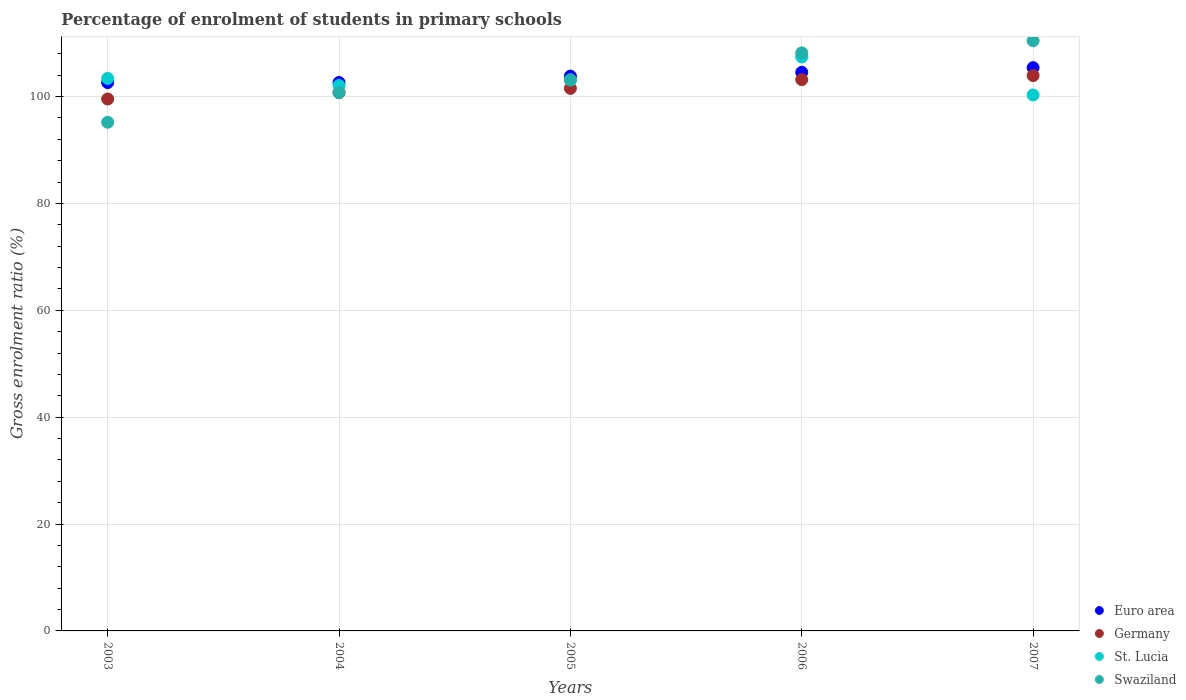How many different coloured dotlines are there?
Offer a very short reply. 4. What is the percentage of students enrolled in primary schools in St. Lucia in 2007?
Your answer should be compact. 100.3. Across all years, what is the maximum percentage of students enrolled in primary schools in Swaziland?
Keep it short and to the point. 110.46. Across all years, what is the minimum percentage of students enrolled in primary schools in Euro area?
Offer a very short reply. 102.61. In which year was the percentage of students enrolled in primary schools in Swaziland minimum?
Offer a terse response. 2003. What is the total percentage of students enrolled in primary schools in Germany in the graph?
Provide a short and direct response. 508.88. What is the difference between the percentage of students enrolled in primary schools in Euro area in 2003 and that in 2005?
Give a very brief answer. -1.21. What is the difference between the percentage of students enrolled in primary schools in Germany in 2006 and the percentage of students enrolled in primary schools in St. Lucia in 2007?
Offer a very short reply. 2.87. What is the average percentage of students enrolled in primary schools in Swaziland per year?
Offer a terse response. 103.54. In the year 2005, what is the difference between the percentage of students enrolled in primary schools in Euro area and percentage of students enrolled in primary schools in Swaziland?
Offer a very short reply. 0.67. In how many years, is the percentage of students enrolled in primary schools in Swaziland greater than 100 %?
Your answer should be very brief. 4. What is the ratio of the percentage of students enrolled in primary schools in Euro area in 2003 to that in 2005?
Offer a terse response. 0.99. What is the difference between the highest and the second highest percentage of students enrolled in primary schools in Euro area?
Provide a short and direct response. 0.86. What is the difference between the highest and the lowest percentage of students enrolled in primary schools in Euro area?
Keep it short and to the point. 2.79. Does the percentage of students enrolled in primary schools in St. Lucia monotonically increase over the years?
Offer a terse response. No. Is the percentage of students enrolled in primary schools in St. Lucia strictly greater than the percentage of students enrolled in primary schools in Swaziland over the years?
Give a very brief answer. No. How many years are there in the graph?
Keep it short and to the point. 5. What is the difference between two consecutive major ticks on the Y-axis?
Your response must be concise. 20. Are the values on the major ticks of Y-axis written in scientific E-notation?
Offer a terse response. No. Does the graph contain any zero values?
Provide a succinct answer. No. Where does the legend appear in the graph?
Make the answer very short. Bottom right. What is the title of the graph?
Provide a short and direct response. Percentage of enrolment of students in primary schools. What is the Gross enrolment ratio (%) in Euro area in 2003?
Your response must be concise. 102.61. What is the Gross enrolment ratio (%) of Germany in 2003?
Give a very brief answer. 99.54. What is the Gross enrolment ratio (%) of St. Lucia in 2003?
Make the answer very short. 103.39. What is the Gross enrolment ratio (%) of Swaziland in 2003?
Your answer should be compact. 95.19. What is the Gross enrolment ratio (%) in Euro area in 2004?
Offer a very short reply. 102.63. What is the Gross enrolment ratio (%) of Germany in 2004?
Provide a short and direct response. 100.72. What is the Gross enrolment ratio (%) in St. Lucia in 2004?
Your response must be concise. 102.07. What is the Gross enrolment ratio (%) of Swaziland in 2004?
Offer a very short reply. 100.73. What is the Gross enrolment ratio (%) of Euro area in 2005?
Give a very brief answer. 103.82. What is the Gross enrolment ratio (%) in Germany in 2005?
Ensure brevity in your answer.  101.53. What is the Gross enrolment ratio (%) of St. Lucia in 2005?
Provide a short and direct response. 103.08. What is the Gross enrolment ratio (%) in Swaziland in 2005?
Provide a short and direct response. 103.14. What is the Gross enrolment ratio (%) in Euro area in 2006?
Give a very brief answer. 104.54. What is the Gross enrolment ratio (%) of Germany in 2006?
Your answer should be compact. 103.17. What is the Gross enrolment ratio (%) of St. Lucia in 2006?
Give a very brief answer. 107.41. What is the Gross enrolment ratio (%) of Swaziland in 2006?
Ensure brevity in your answer.  108.17. What is the Gross enrolment ratio (%) in Euro area in 2007?
Ensure brevity in your answer.  105.4. What is the Gross enrolment ratio (%) in Germany in 2007?
Ensure brevity in your answer.  103.93. What is the Gross enrolment ratio (%) in St. Lucia in 2007?
Give a very brief answer. 100.3. What is the Gross enrolment ratio (%) of Swaziland in 2007?
Make the answer very short. 110.46. Across all years, what is the maximum Gross enrolment ratio (%) of Euro area?
Give a very brief answer. 105.4. Across all years, what is the maximum Gross enrolment ratio (%) of Germany?
Offer a very short reply. 103.93. Across all years, what is the maximum Gross enrolment ratio (%) in St. Lucia?
Offer a very short reply. 107.41. Across all years, what is the maximum Gross enrolment ratio (%) in Swaziland?
Offer a terse response. 110.46. Across all years, what is the minimum Gross enrolment ratio (%) in Euro area?
Your response must be concise. 102.61. Across all years, what is the minimum Gross enrolment ratio (%) of Germany?
Provide a short and direct response. 99.54. Across all years, what is the minimum Gross enrolment ratio (%) of St. Lucia?
Provide a succinct answer. 100.3. Across all years, what is the minimum Gross enrolment ratio (%) in Swaziland?
Make the answer very short. 95.19. What is the total Gross enrolment ratio (%) in Euro area in the graph?
Make the answer very short. 519. What is the total Gross enrolment ratio (%) in Germany in the graph?
Your answer should be very brief. 508.88. What is the total Gross enrolment ratio (%) of St. Lucia in the graph?
Your answer should be compact. 516.24. What is the total Gross enrolment ratio (%) of Swaziland in the graph?
Offer a very short reply. 517.69. What is the difference between the Gross enrolment ratio (%) in Euro area in 2003 and that in 2004?
Ensure brevity in your answer.  -0.02. What is the difference between the Gross enrolment ratio (%) of Germany in 2003 and that in 2004?
Provide a succinct answer. -1.18. What is the difference between the Gross enrolment ratio (%) in St. Lucia in 2003 and that in 2004?
Offer a very short reply. 1.33. What is the difference between the Gross enrolment ratio (%) of Swaziland in 2003 and that in 2004?
Make the answer very short. -5.55. What is the difference between the Gross enrolment ratio (%) in Euro area in 2003 and that in 2005?
Keep it short and to the point. -1.21. What is the difference between the Gross enrolment ratio (%) of Germany in 2003 and that in 2005?
Your response must be concise. -1.99. What is the difference between the Gross enrolment ratio (%) of St. Lucia in 2003 and that in 2005?
Your answer should be compact. 0.31. What is the difference between the Gross enrolment ratio (%) of Swaziland in 2003 and that in 2005?
Provide a succinct answer. -7.96. What is the difference between the Gross enrolment ratio (%) of Euro area in 2003 and that in 2006?
Your answer should be compact. -1.93. What is the difference between the Gross enrolment ratio (%) of Germany in 2003 and that in 2006?
Give a very brief answer. -3.63. What is the difference between the Gross enrolment ratio (%) in St. Lucia in 2003 and that in 2006?
Offer a terse response. -4.01. What is the difference between the Gross enrolment ratio (%) in Swaziland in 2003 and that in 2006?
Offer a terse response. -12.98. What is the difference between the Gross enrolment ratio (%) in Euro area in 2003 and that in 2007?
Give a very brief answer. -2.79. What is the difference between the Gross enrolment ratio (%) in Germany in 2003 and that in 2007?
Give a very brief answer. -4.39. What is the difference between the Gross enrolment ratio (%) of St. Lucia in 2003 and that in 2007?
Offer a very short reply. 3.1. What is the difference between the Gross enrolment ratio (%) in Swaziland in 2003 and that in 2007?
Your response must be concise. -15.27. What is the difference between the Gross enrolment ratio (%) of Euro area in 2004 and that in 2005?
Keep it short and to the point. -1.19. What is the difference between the Gross enrolment ratio (%) in Germany in 2004 and that in 2005?
Offer a very short reply. -0.81. What is the difference between the Gross enrolment ratio (%) in St. Lucia in 2004 and that in 2005?
Give a very brief answer. -1.02. What is the difference between the Gross enrolment ratio (%) in Swaziland in 2004 and that in 2005?
Provide a succinct answer. -2.41. What is the difference between the Gross enrolment ratio (%) of Euro area in 2004 and that in 2006?
Ensure brevity in your answer.  -1.91. What is the difference between the Gross enrolment ratio (%) in Germany in 2004 and that in 2006?
Your answer should be compact. -2.45. What is the difference between the Gross enrolment ratio (%) in St. Lucia in 2004 and that in 2006?
Keep it short and to the point. -5.34. What is the difference between the Gross enrolment ratio (%) of Swaziland in 2004 and that in 2006?
Make the answer very short. -7.43. What is the difference between the Gross enrolment ratio (%) of Euro area in 2004 and that in 2007?
Offer a terse response. -2.77. What is the difference between the Gross enrolment ratio (%) in Germany in 2004 and that in 2007?
Keep it short and to the point. -3.21. What is the difference between the Gross enrolment ratio (%) of St. Lucia in 2004 and that in 2007?
Ensure brevity in your answer.  1.77. What is the difference between the Gross enrolment ratio (%) of Swaziland in 2004 and that in 2007?
Provide a succinct answer. -9.72. What is the difference between the Gross enrolment ratio (%) in Euro area in 2005 and that in 2006?
Keep it short and to the point. -0.72. What is the difference between the Gross enrolment ratio (%) in Germany in 2005 and that in 2006?
Keep it short and to the point. -1.64. What is the difference between the Gross enrolment ratio (%) of St. Lucia in 2005 and that in 2006?
Provide a short and direct response. -4.32. What is the difference between the Gross enrolment ratio (%) in Swaziland in 2005 and that in 2006?
Your answer should be very brief. -5.02. What is the difference between the Gross enrolment ratio (%) of Euro area in 2005 and that in 2007?
Give a very brief answer. -1.58. What is the difference between the Gross enrolment ratio (%) in Germany in 2005 and that in 2007?
Your answer should be compact. -2.4. What is the difference between the Gross enrolment ratio (%) of St. Lucia in 2005 and that in 2007?
Offer a terse response. 2.79. What is the difference between the Gross enrolment ratio (%) in Swaziland in 2005 and that in 2007?
Provide a succinct answer. -7.31. What is the difference between the Gross enrolment ratio (%) in Euro area in 2006 and that in 2007?
Your answer should be very brief. -0.86. What is the difference between the Gross enrolment ratio (%) in Germany in 2006 and that in 2007?
Keep it short and to the point. -0.76. What is the difference between the Gross enrolment ratio (%) of St. Lucia in 2006 and that in 2007?
Provide a short and direct response. 7.11. What is the difference between the Gross enrolment ratio (%) in Swaziland in 2006 and that in 2007?
Your response must be concise. -2.29. What is the difference between the Gross enrolment ratio (%) in Euro area in 2003 and the Gross enrolment ratio (%) in Germany in 2004?
Your response must be concise. 1.89. What is the difference between the Gross enrolment ratio (%) in Euro area in 2003 and the Gross enrolment ratio (%) in St. Lucia in 2004?
Provide a succinct answer. 0.55. What is the difference between the Gross enrolment ratio (%) in Euro area in 2003 and the Gross enrolment ratio (%) in Swaziland in 2004?
Ensure brevity in your answer.  1.88. What is the difference between the Gross enrolment ratio (%) of Germany in 2003 and the Gross enrolment ratio (%) of St. Lucia in 2004?
Offer a very short reply. -2.53. What is the difference between the Gross enrolment ratio (%) in Germany in 2003 and the Gross enrolment ratio (%) in Swaziland in 2004?
Make the answer very short. -1.19. What is the difference between the Gross enrolment ratio (%) of St. Lucia in 2003 and the Gross enrolment ratio (%) of Swaziland in 2004?
Your answer should be very brief. 2.66. What is the difference between the Gross enrolment ratio (%) in Euro area in 2003 and the Gross enrolment ratio (%) in St. Lucia in 2005?
Offer a very short reply. -0.47. What is the difference between the Gross enrolment ratio (%) of Euro area in 2003 and the Gross enrolment ratio (%) of Swaziland in 2005?
Your response must be concise. -0.53. What is the difference between the Gross enrolment ratio (%) in Germany in 2003 and the Gross enrolment ratio (%) in St. Lucia in 2005?
Your answer should be compact. -3.54. What is the difference between the Gross enrolment ratio (%) in Germany in 2003 and the Gross enrolment ratio (%) in Swaziland in 2005?
Make the answer very short. -3.61. What is the difference between the Gross enrolment ratio (%) of St. Lucia in 2003 and the Gross enrolment ratio (%) of Swaziland in 2005?
Give a very brief answer. 0.25. What is the difference between the Gross enrolment ratio (%) of Euro area in 2003 and the Gross enrolment ratio (%) of Germany in 2006?
Provide a succinct answer. -0.56. What is the difference between the Gross enrolment ratio (%) of Euro area in 2003 and the Gross enrolment ratio (%) of St. Lucia in 2006?
Your answer should be very brief. -4.8. What is the difference between the Gross enrolment ratio (%) of Euro area in 2003 and the Gross enrolment ratio (%) of Swaziland in 2006?
Give a very brief answer. -5.56. What is the difference between the Gross enrolment ratio (%) of Germany in 2003 and the Gross enrolment ratio (%) of St. Lucia in 2006?
Provide a succinct answer. -7.87. What is the difference between the Gross enrolment ratio (%) of Germany in 2003 and the Gross enrolment ratio (%) of Swaziland in 2006?
Provide a succinct answer. -8.63. What is the difference between the Gross enrolment ratio (%) in St. Lucia in 2003 and the Gross enrolment ratio (%) in Swaziland in 2006?
Your answer should be compact. -4.78. What is the difference between the Gross enrolment ratio (%) in Euro area in 2003 and the Gross enrolment ratio (%) in Germany in 2007?
Your answer should be compact. -1.32. What is the difference between the Gross enrolment ratio (%) of Euro area in 2003 and the Gross enrolment ratio (%) of St. Lucia in 2007?
Your response must be concise. 2.31. What is the difference between the Gross enrolment ratio (%) of Euro area in 2003 and the Gross enrolment ratio (%) of Swaziland in 2007?
Keep it short and to the point. -7.85. What is the difference between the Gross enrolment ratio (%) of Germany in 2003 and the Gross enrolment ratio (%) of St. Lucia in 2007?
Your answer should be very brief. -0.76. What is the difference between the Gross enrolment ratio (%) in Germany in 2003 and the Gross enrolment ratio (%) in Swaziland in 2007?
Ensure brevity in your answer.  -10.92. What is the difference between the Gross enrolment ratio (%) of St. Lucia in 2003 and the Gross enrolment ratio (%) of Swaziland in 2007?
Your answer should be very brief. -7.07. What is the difference between the Gross enrolment ratio (%) of Euro area in 2004 and the Gross enrolment ratio (%) of Germany in 2005?
Make the answer very short. 1.1. What is the difference between the Gross enrolment ratio (%) in Euro area in 2004 and the Gross enrolment ratio (%) in St. Lucia in 2005?
Offer a terse response. -0.45. What is the difference between the Gross enrolment ratio (%) in Euro area in 2004 and the Gross enrolment ratio (%) in Swaziland in 2005?
Provide a succinct answer. -0.51. What is the difference between the Gross enrolment ratio (%) in Germany in 2004 and the Gross enrolment ratio (%) in St. Lucia in 2005?
Offer a terse response. -2.36. What is the difference between the Gross enrolment ratio (%) of Germany in 2004 and the Gross enrolment ratio (%) of Swaziland in 2005?
Give a very brief answer. -2.42. What is the difference between the Gross enrolment ratio (%) of St. Lucia in 2004 and the Gross enrolment ratio (%) of Swaziland in 2005?
Offer a terse response. -1.08. What is the difference between the Gross enrolment ratio (%) of Euro area in 2004 and the Gross enrolment ratio (%) of Germany in 2006?
Keep it short and to the point. -0.54. What is the difference between the Gross enrolment ratio (%) of Euro area in 2004 and the Gross enrolment ratio (%) of St. Lucia in 2006?
Keep it short and to the point. -4.78. What is the difference between the Gross enrolment ratio (%) of Euro area in 2004 and the Gross enrolment ratio (%) of Swaziland in 2006?
Provide a succinct answer. -5.54. What is the difference between the Gross enrolment ratio (%) in Germany in 2004 and the Gross enrolment ratio (%) in St. Lucia in 2006?
Your answer should be compact. -6.69. What is the difference between the Gross enrolment ratio (%) in Germany in 2004 and the Gross enrolment ratio (%) in Swaziland in 2006?
Provide a short and direct response. -7.45. What is the difference between the Gross enrolment ratio (%) in St. Lucia in 2004 and the Gross enrolment ratio (%) in Swaziland in 2006?
Offer a terse response. -6.1. What is the difference between the Gross enrolment ratio (%) in Euro area in 2004 and the Gross enrolment ratio (%) in Germany in 2007?
Provide a succinct answer. -1.3. What is the difference between the Gross enrolment ratio (%) in Euro area in 2004 and the Gross enrolment ratio (%) in St. Lucia in 2007?
Offer a very short reply. 2.33. What is the difference between the Gross enrolment ratio (%) of Euro area in 2004 and the Gross enrolment ratio (%) of Swaziland in 2007?
Offer a terse response. -7.83. What is the difference between the Gross enrolment ratio (%) in Germany in 2004 and the Gross enrolment ratio (%) in St. Lucia in 2007?
Make the answer very short. 0.42. What is the difference between the Gross enrolment ratio (%) of Germany in 2004 and the Gross enrolment ratio (%) of Swaziland in 2007?
Your answer should be very brief. -9.74. What is the difference between the Gross enrolment ratio (%) in St. Lucia in 2004 and the Gross enrolment ratio (%) in Swaziland in 2007?
Your response must be concise. -8.39. What is the difference between the Gross enrolment ratio (%) of Euro area in 2005 and the Gross enrolment ratio (%) of Germany in 2006?
Give a very brief answer. 0.65. What is the difference between the Gross enrolment ratio (%) of Euro area in 2005 and the Gross enrolment ratio (%) of St. Lucia in 2006?
Your response must be concise. -3.59. What is the difference between the Gross enrolment ratio (%) of Euro area in 2005 and the Gross enrolment ratio (%) of Swaziland in 2006?
Make the answer very short. -4.35. What is the difference between the Gross enrolment ratio (%) in Germany in 2005 and the Gross enrolment ratio (%) in St. Lucia in 2006?
Your response must be concise. -5.88. What is the difference between the Gross enrolment ratio (%) of Germany in 2005 and the Gross enrolment ratio (%) of Swaziland in 2006?
Your response must be concise. -6.64. What is the difference between the Gross enrolment ratio (%) of St. Lucia in 2005 and the Gross enrolment ratio (%) of Swaziland in 2006?
Your response must be concise. -5.09. What is the difference between the Gross enrolment ratio (%) in Euro area in 2005 and the Gross enrolment ratio (%) in Germany in 2007?
Keep it short and to the point. -0.11. What is the difference between the Gross enrolment ratio (%) of Euro area in 2005 and the Gross enrolment ratio (%) of St. Lucia in 2007?
Your answer should be compact. 3.52. What is the difference between the Gross enrolment ratio (%) of Euro area in 2005 and the Gross enrolment ratio (%) of Swaziland in 2007?
Offer a terse response. -6.64. What is the difference between the Gross enrolment ratio (%) of Germany in 2005 and the Gross enrolment ratio (%) of St. Lucia in 2007?
Offer a terse response. 1.23. What is the difference between the Gross enrolment ratio (%) of Germany in 2005 and the Gross enrolment ratio (%) of Swaziland in 2007?
Your answer should be very brief. -8.93. What is the difference between the Gross enrolment ratio (%) in St. Lucia in 2005 and the Gross enrolment ratio (%) in Swaziland in 2007?
Your answer should be compact. -7.37. What is the difference between the Gross enrolment ratio (%) of Euro area in 2006 and the Gross enrolment ratio (%) of Germany in 2007?
Give a very brief answer. 0.61. What is the difference between the Gross enrolment ratio (%) of Euro area in 2006 and the Gross enrolment ratio (%) of St. Lucia in 2007?
Keep it short and to the point. 4.24. What is the difference between the Gross enrolment ratio (%) in Euro area in 2006 and the Gross enrolment ratio (%) in Swaziland in 2007?
Your answer should be very brief. -5.92. What is the difference between the Gross enrolment ratio (%) of Germany in 2006 and the Gross enrolment ratio (%) of St. Lucia in 2007?
Keep it short and to the point. 2.87. What is the difference between the Gross enrolment ratio (%) in Germany in 2006 and the Gross enrolment ratio (%) in Swaziland in 2007?
Give a very brief answer. -7.29. What is the difference between the Gross enrolment ratio (%) in St. Lucia in 2006 and the Gross enrolment ratio (%) in Swaziland in 2007?
Your response must be concise. -3.05. What is the average Gross enrolment ratio (%) of Euro area per year?
Make the answer very short. 103.8. What is the average Gross enrolment ratio (%) of Germany per year?
Your answer should be very brief. 101.78. What is the average Gross enrolment ratio (%) in St. Lucia per year?
Your answer should be very brief. 103.25. What is the average Gross enrolment ratio (%) of Swaziland per year?
Give a very brief answer. 103.54. In the year 2003, what is the difference between the Gross enrolment ratio (%) of Euro area and Gross enrolment ratio (%) of Germany?
Your response must be concise. 3.07. In the year 2003, what is the difference between the Gross enrolment ratio (%) of Euro area and Gross enrolment ratio (%) of St. Lucia?
Offer a terse response. -0.78. In the year 2003, what is the difference between the Gross enrolment ratio (%) of Euro area and Gross enrolment ratio (%) of Swaziland?
Offer a very short reply. 7.42. In the year 2003, what is the difference between the Gross enrolment ratio (%) of Germany and Gross enrolment ratio (%) of St. Lucia?
Provide a short and direct response. -3.85. In the year 2003, what is the difference between the Gross enrolment ratio (%) in Germany and Gross enrolment ratio (%) in Swaziland?
Keep it short and to the point. 4.35. In the year 2003, what is the difference between the Gross enrolment ratio (%) in St. Lucia and Gross enrolment ratio (%) in Swaziland?
Ensure brevity in your answer.  8.21. In the year 2004, what is the difference between the Gross enrolment ratio (%) in Euro area and Gross enrolment ratio (%) in Germany?
Provide a succinct answer. 1.91. In the year 2004, what is the difference between the Gross enrolment ratio (%) of Euro area and Gross enrolment ratio (%) of St. Lucia?
Your response must be concise. 0.57. In the year 2004, what is the difference between the Gross enrolment ratio (%) in Euro area and Gross enrolment ratio (%) in Swaziland?
Provide a short and direct response. 1.9. In the year 2004, what is the difference between the Gross enrolment ratio (%) of Germany and Gross enrolment ratio (%) of St. Lucia?
Your answer should be very brief. -1.35. In the year 2004, what is the difference between the Gross enrolment ratio (%) of Germany and Gross enrolment ratio (%) of Swaziland?
Your response must be concise. -0.01. In the year 2004, what is the difference between the Gross enrolment ratio (%) in St. Lucia and Gross enrolment ratio (%) in Swaziland?
Your answer should be compact. 1.33. In the year 2005, what is the difference between the Gross enrolment ratio (%) in Euro area and Gross enrolment ratio (%) in Germany?
Offer a very short reply. 2.29. In the year 2005, what is the difference between the Gross enrolment ratio (%) of Euro area and Gross enrolment ratio (%) of St. Lucia?
Keep it short and to the point. 0.74. In the year 2005, what is the difference between the Gross enrolment ratio (%) of Euro area and Gross enrolment ratio (%) of Swaziland?
Provide a succinct answer. 0.67. In the year 2005, what is the difference between the Gross enrolment ratio (%) in Germany and Gross enrolment ratio (%) in St. Lucia?
Offer a very short reply. -1.56. In the year 2005, what is the difference between the Gross enrolment ratio (%) in Germany and Gross enrolment ratio (%) in Swaziland?
Offer a very short reply. -1.62. In the year 2005, what is the difference between the Gross enrolment ratio (%) in St. Lucia and Gross enrolment ratio (%) in Swaziland?
Give a very brief answer. -0.06. In the year 2006, what is the difference between the Gross enrolment ratio (%) in Euro area and Gross enrolment ratio (%) in Germany?
Make the answer very short. 1.37. In the year 2006, what is the difference between the Gross enrolment ratio (%) of Euro area and Gross enrolment ratio (%) of St. Lucia?
Your answer should be very brief. -2.87. In the year 2006, what is the difference between the Gross enrolment ratio (%) in Euro area and Gross enrolment ratio (%) in Swaziland?
Keep it short and to the point. -3.63. In the year 2006, what is the difference between the Gross enrolment ratio (%) in Germany and Gross enrolment ratio (%) in St. Lucia?
Give a very brief answer. -4.24. In the year 2006, what is the difference between the Gross enrolment ratio (%) in Germany and Gross enrolment ratio (%) in Swaziland?
Your response must be concise. -5. In the year 2006, what is the difference between the Gross enrolment ratio (%) of St. Lucia and Gross enrolment ratio (%) of Swaziland?
Give a very brief answer. -0.76. In the year 2007, what is the difference between the Gross enrolment ratio (%) of Euro area and Gross enrolment ratio (%) of Germany?
Give a very brief answer. 1.48. In the year 2007, what is the difference between the Gross enrolment ratio (%) in Euro area and Gross enrolment ratio (%) in St. Lucia?
Give a very brief answer. 5.11. In the year 2007, what is the difference between the Gross enrolment ratio (%) of Euro area and Gross enrolment ratio (%) of Swaziland?
Your answer should be very brief. -5.06. In the year 2007, what is the difference between the Gross enrolment ratio (%) in Germany and Gross enrolment ratio (%) in St. Lucia?
Your response must be concise. 3.63. In the year 2007, what is the difference between the Gross enrolment ratio (%) in Germany and Gross enrolment ratio (%) in Swaziland?
Provide a succinct answer. -6.53. In the year 2007, what is the difference between the Gross enrolment ratio (%) in St. Lucia and Gross enrolment ratio (%) in Swaziland?
Ensure brevity in your answer.  -10.16. What is the ratio of the Gross enrolment ratio (%) of Germany in 2003 to that in 2004?
Your answer should be very brief. 0.99. What is the ratio of the Gross enrolment ratio (%) in Swaziland in 2003 to that in 2004?
Provide a short and direct response. 0.94. What is the ratio of the Gross enrolment ratio (%) of Euro area in 2003 to that in 2005?
Your answer should be very brief. 0.99. What is the ratio of the Gross enrolment ratio (%) of Germany in 2003 to that in 2005?
Offer a terse response. 0.98. What is the ratio of the Gross enrolment ratio (%) in Swaziland in 2003 to that in 2005?
Your response must be concise. 0.92. What is the ratio of the Gross enrolment ratio (%) of Euro area in 2003 to that in 2006?
Your answer should be very brief. 0.98. What is the ratio of the Gross enrolment ratio (%) of Germany in 2003 to that in 2006?
Your answer should be compact. 0.96. What is the ratio of the Gross enrolment ratio (%) in St. Lucia in 2003 to that in 2006?
Give a very brief answer. 0.96. What is the ratio of the Gross enrolment ratio (%) of Swaziland in 2003 to that in 2006?
Your answer should be very brief. 0.88. What is the ratio of the Gross enrolment ratio (%) of Euro area in 2003 to that in 2007?
Provide a short and direct response. 0.97. What is the ratio of the Gross enrolment ratio (%) in Germany in 2003 to that in 2007?
Your answer should be very brief. 0.96. What is the ratio of the Gross enrolment ratio (%) in St. Lucia in 2003 to that in 2007?
Give a very brief answer. 1.03. What is the ratio of the Gross enrolment ratio (%) of Swaziland in 2003 to that in 2007?
Your answer should be compact. 0.86. What is the ratio of the Gross enrolment ratio (%) of Germany in 2004 to that in 2005?
Make the answer very short. 0.99. What is the ratio of the Gross enrolment ratio (%) of St. Lucia in 2004 to that in 2005?
Offer a very short reply. 0.99. What is the ratio of the Gross enrolment ratio (%) in Swaziland in 2004 to that in 2005?
Your response must be concise. 0.98. What is the ratio of the Gross enrolment ratio (%) of Euro area in 2004 to that in 2006?
Ensure brevity in your answer.  0.98. What is the ratio of the Gross enrolment ratio (%) in Germany in 2004 to that in 2006?
Provide a short and direct response. 0.98. What is the ratio of the Gross enrolment ratio (%) of St. Lucia in 2004 to that in 2006?
Your answer should be very brief. 0.95. What is the ratio of the Gross enrolment ratio (%) of Swaziland in 2004 to that in 2006?
Offer a very short reply. 0.93. What is the ratio of the Gross enrolment ratio (%) of Euro area in 2004 to that in 2007?
Give a very brief answer. 0.97. What is the ratio of the Gross enrolment ratio (%) in Germany in 2004 to that in 2007?
Provide a succinct answer. 0.97. What is the ratio of the Gross enrolment ratio (%) of St. Lucia in 2004 to that in 2007?
Provide a short and direct response. 1.02. What is the ratio of the Gross enrolment ratio (%) in Swaziland in 2004 to that in 2007?
Offer a very short reply. 0.91. What is the ratio of the Gross enrolment ratio (%) of Germany in 2005 to that in 2006?
Offer a very short reply. 0.98. What is the ratio of the Gross enrolment ratio (%) in St. Lucia in 2005 to that in 2006?
Ensure brevity in your answer.  0.96. What is the ratio of the Gross enrolment ratio (%) of Swaziland in 2005 to that in 2006?
Keep it short and to the point. 0.95. What is the ratio of the Gross enrolment ratio (%) of Euro area in 2005 to that in 2007?
Give a very brief answer. 0.98. What is the ratio of the Gross enrolment ratio (%) of Germany in 2005 to that in 2007?
Ensure brevity in your answer.  0.98. What is the ratio of the Gross enrolment ratio (%) of St. Lucia in 2005 to that in 2007?
Your response must be concise. 1.03. What is the ratio of the Gross enrolment ratio (%) of Swaziland in 2005 to that in 2007?
Provide a short and direct response. 0.93. What is the ratio of the Gross enrolment ratio (%) of St. Lucia in 2006 to that in 2007?
Ensure brevity in your answer.  1.07. What is the ratio of the Gross enrolment ratio (%) in Swaziland in 2006 to that in 2007?
Make the answer very short. 0.98. What is the difference between the highest and the second highest Gross enrolment ratio (%) in Euro area?
Provide a succinct answer. 0.86. What is the difference between the highest and the second highest Gross enrolment ratio (%) in Germany?
Your answer should be compact. 0.76. What is the difference between the highest and the second highest Gross enrolment ratio (%) of St. Lucia?
Keep it short and to the point. 4.01. What is the difference between the highest and the second highest Gross enrolment ratio (%) of Swaziland?
Give a very brief answer. 2.29. What is the difference between the highest and the lowest Gross enrolment ratio (%) of Euro area?
Your answer should be compact. 2.79. What is the difference between the highest and the lowest Gross enrolment ratio (%) of Germany?
Make the answer very short. 4.39. What is the difference between the highest and the lowest Gross enrolment ratio (%) of St. Lucia?
Your answer should be very brief. 7.11. What is the difference between the highest and the lowest Gross enrolment ratio (%) in Swaziland?
Your response must be concise. 15.27. 